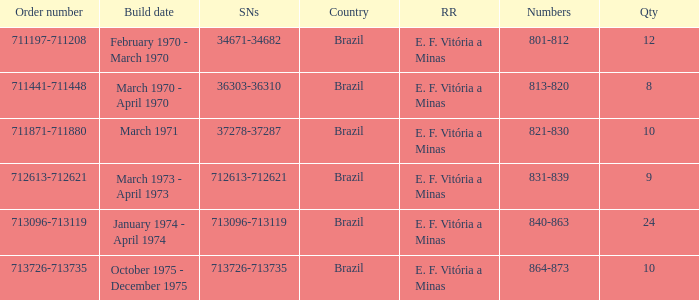The serial numbers 713096-713119 are in which country? Brazil. 